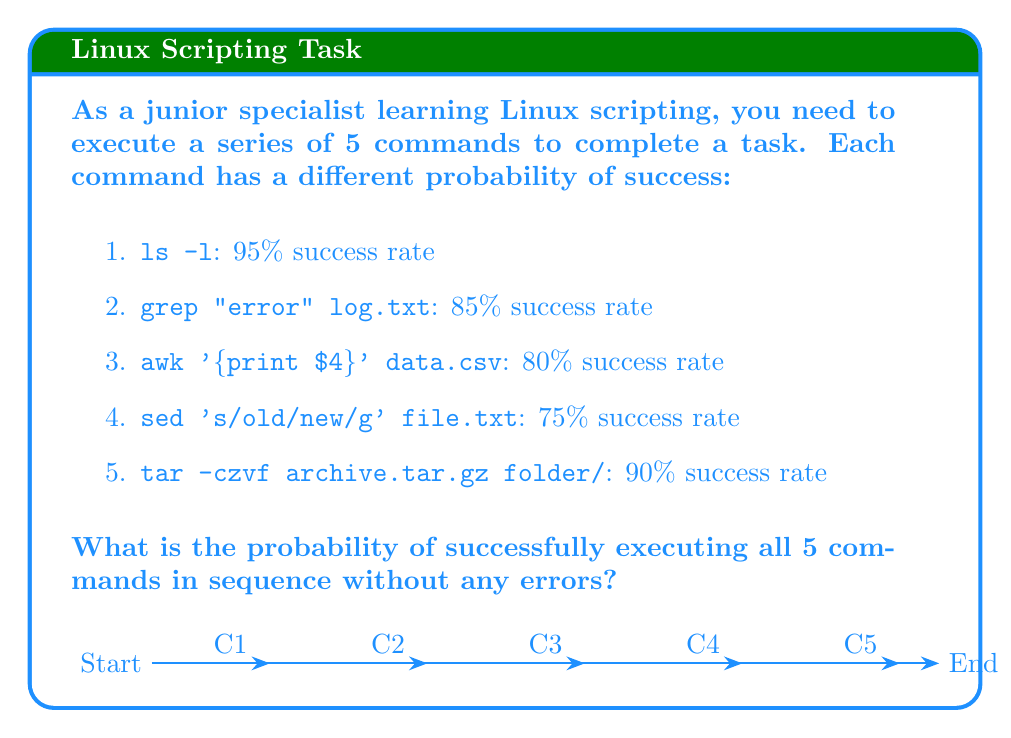Can you answer this question? To solve this problem, we need to follow these steps:

1. Understand that for all commands to succeed, each individual command must succeed.
2. Recognize that this scenario represents independent events.
3. Calculate the probability of all events occurring together by multiplying the individual probabilities.

Let's break it down:

1. Convert percentages to probabilities:
   - C1: 95% = 0.95
   - C2: 85% = 0.85
   - C3: 80% = 0.80
   - C4: 75% = 0.75
   - C5: 90% = 0.90

2. The probability of all commands succeeding is:

   $$P(\text{all succeed}) = P(C1) \times P(C2) \times P(C3) \times P(C4) \times P(C5)$$

3. Substitute the values:

   $$P(\text{all succeed}) = 0.95 \times 0.85 \times 0.80 \times 0.75 \times 0.90$$

4. Calculate:

   $$P(\text{all succeed}) = 0.4375125$$

5. Convert to percentage:

   $$P(\text{all succeed}) = 0.4375125 \times 100\% = 43.75125\%$$

Therefore, the probability of successfully executing all 5 commands in sequence without any errors is approximately 43.75%.
Answer: $43.75\%$ 